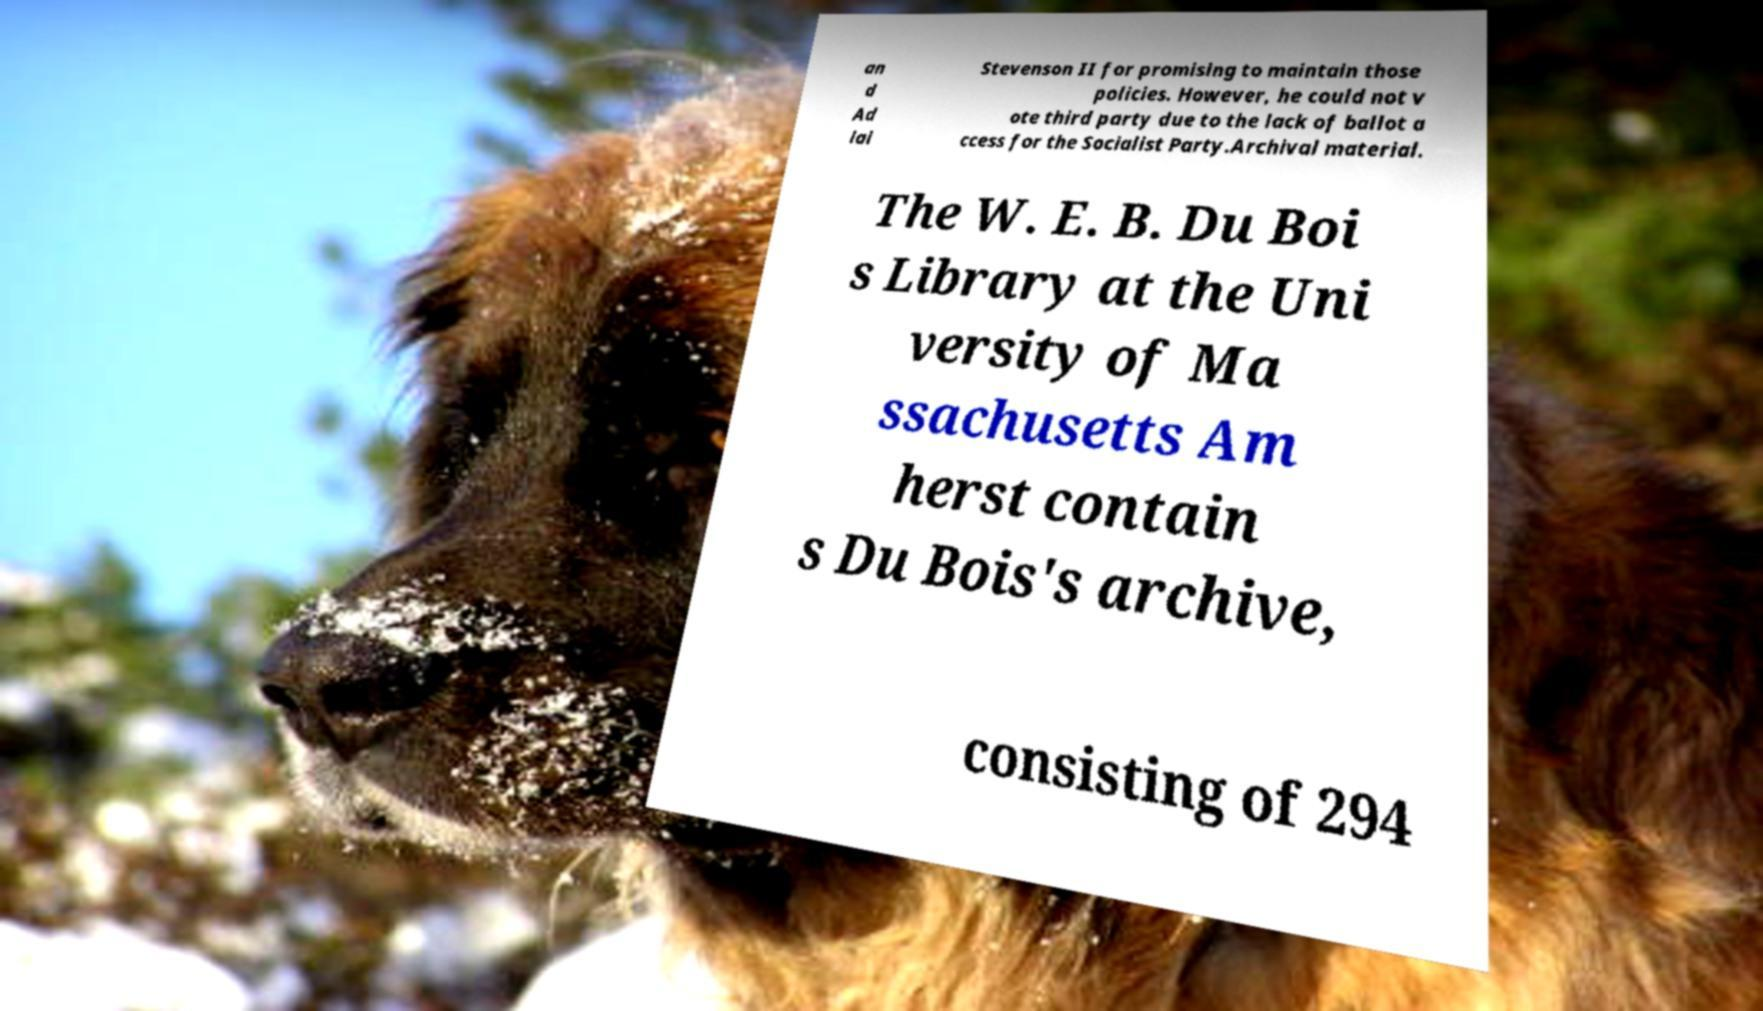Could you assist in decoding the text presented in this image and type it out clearly? an d Ad lai Stevenson II for promising to maintain those policies. However, he could not v ote third party due to the lack of ballot a ccess for the Socialist Party.Archival material. The W. E. B. Du Boi s Library at the Uni versity of Ma ssachusetts Am herst contain s Du Bois's archive, consisting of 294 